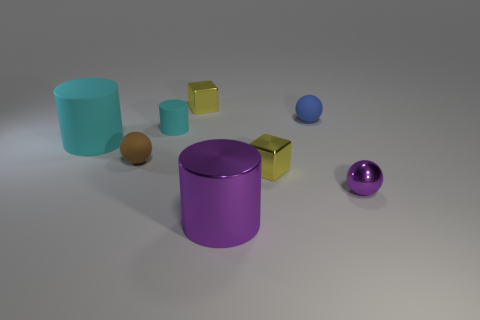The cylinder that is right of the brown rubber thing and behind the shiny sphere is what color?
Make the answer very short. Cyan. The brown object has what size?
Ensure brevity in your answer.  Small. What number of red metal cubes are the same size as the blue object?
Offer a very short reply. 0. Is the tiny yellow object that is right of the big metal object made of the same material as the big cylinder behind the tiny metal sphere?
Ensure brevity in your answer.  No. The large cylinder that is behind the tiny thing that is to the right of the blue matte sphere is made of what material?
Offer a very short reply. Rubber. There is a small cyan thing in front of the small blue object; what material is it?
Keep it short and to the point. Rubber. What number of big purple shiny things are the same shape as the small purple object?
Make the answer very short. 0. Do the tiny cylinder and the large rubber cylinder have the same color?
Your answer should be compact. Yes. The large cyan object that is in front of the small blue object that is behind the large metallic cylinder in front of the tiny cyan thing is made of what material?
Keep it short and to the point. Rubber. There is a small purple metallic sphere; are there any balls behind it?
Ensure brevity in your answer.  Yes. 